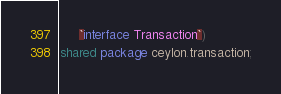<code> <loc_0><loc_0><loc_500><loc_500><_Ceylon_>     `interface Transaction`)
shared package ceylon.transaction;
</code> 